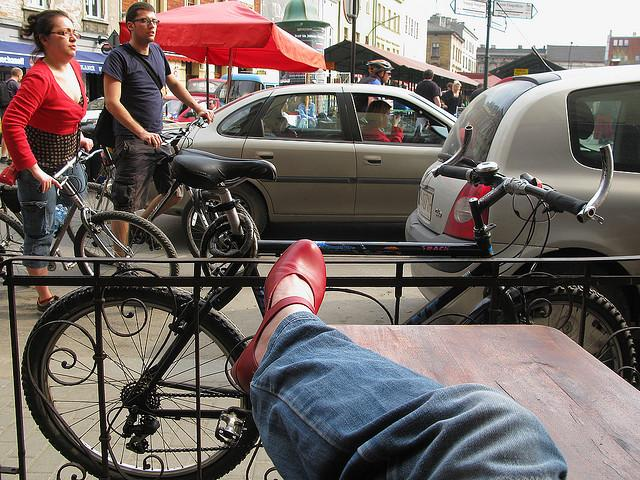How is doing what the photo taker is doing with their leg considered?

Choices:
A) spiritual
B) slightly rude
C) dangerous
D) perfectly normal slightly rude 